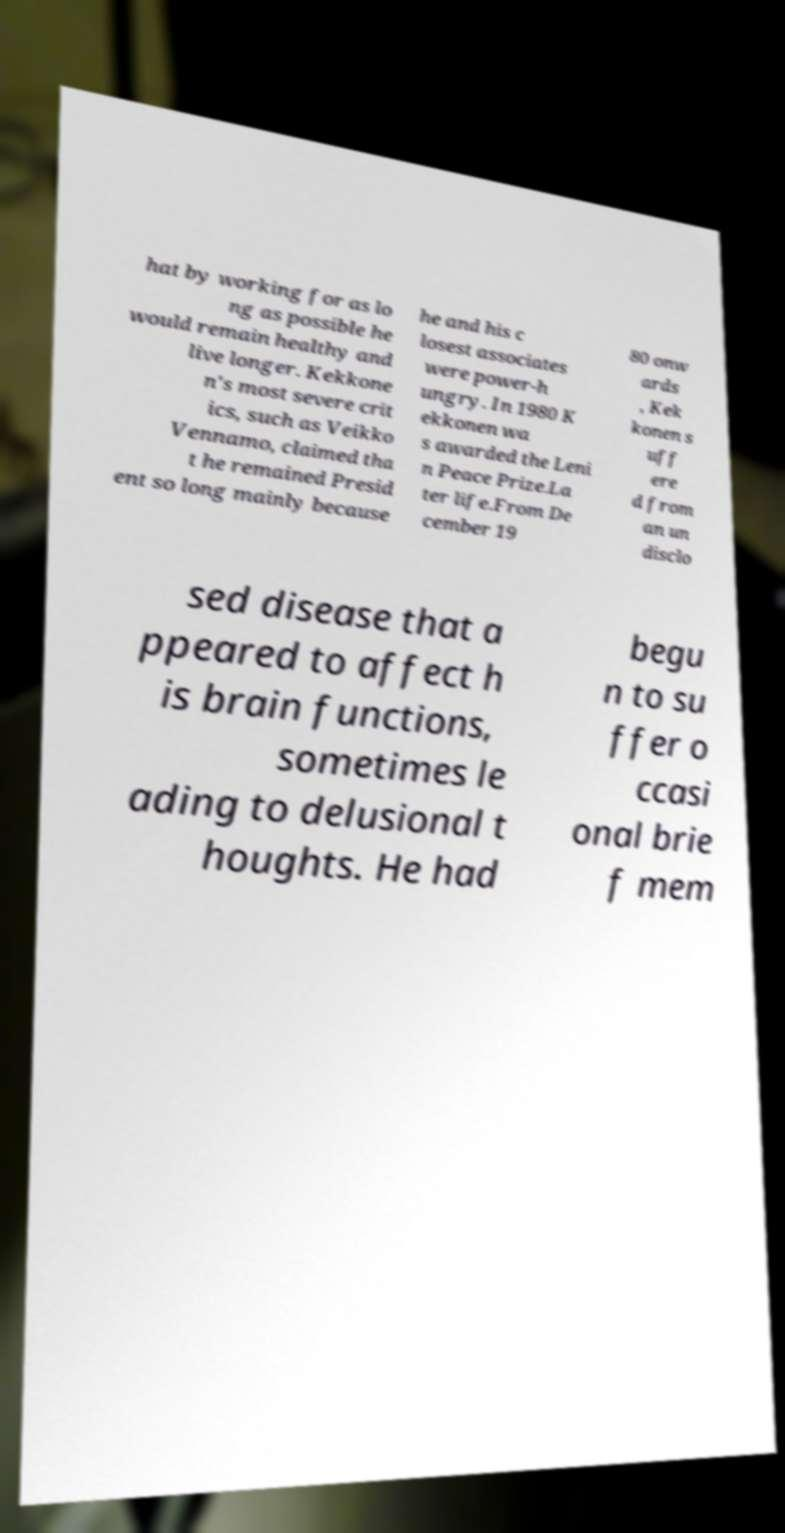I need the written content from this picture converted into text. Can you do that? hat by working for as lo ng as possible he would remain healthy and live longer. Kekkone n's most severe crit ics, such as Veikko Vennamo, claimed tha t he remained Presid ent so long mainly because he and his c losest associates were power-h ungry. In 1980 K ekkonen wa s awarded the Leni n Peace Prize.La ter life.From De cember 19 80 onw ards , Kek konen s uff ere d from an un disclo sed disease that a ppeared to affect h is brain functions, sometimes le ading to delusional t houghts. He had begu n to su ffer o ccasi onal brie f mem 